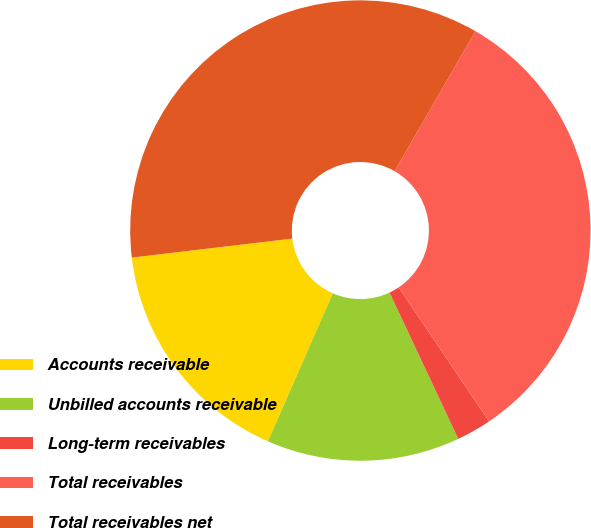Convert chart. <chart><loc_0><loc_0><loc_500><loc_500><pie_chart><fcel>Accounts receivable<fcel>Unbilled accounts receivable<fcel>Long-term receivables<fcel>Total receivables<fcel>Total receivables net<nl><fcel>16.55%<fcel>13.57%<fcel>2.45%<fcel>32.23%<fcel>35.21%<nl></chart> 